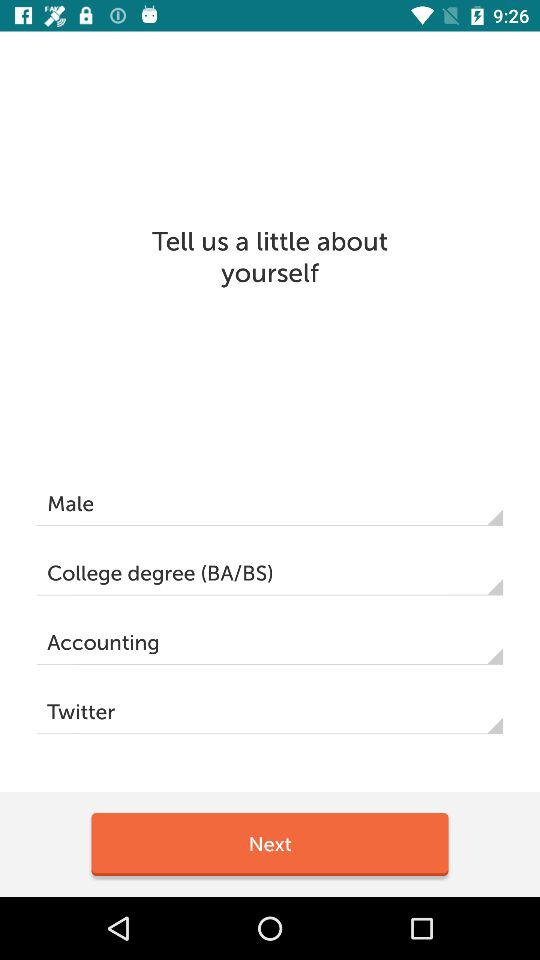How many text inputs have the text 'degree' in them?
Answer the question using a single word or phrase. 1 